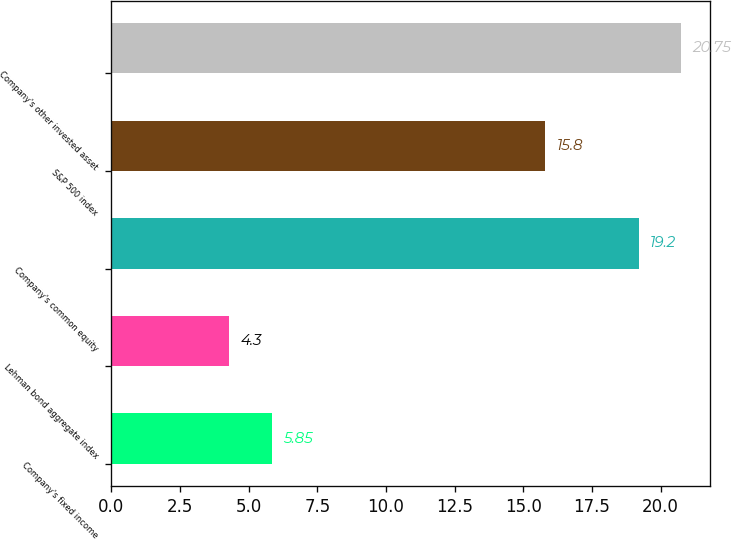Convert chart. <chart><loc_0><loc_0><loc_500><loc_500><bar_chart><fcel>Company's fixed income<fcel>Lehman bond aggregate index<fcel>Company's common equity<fcel>S&P 500 index<fcel>Company's other invested asset<nl><fcel>5.85<fcel>4.3<fcel>19.2<fcel>15.8<fcel>20.75<nl></chart> 